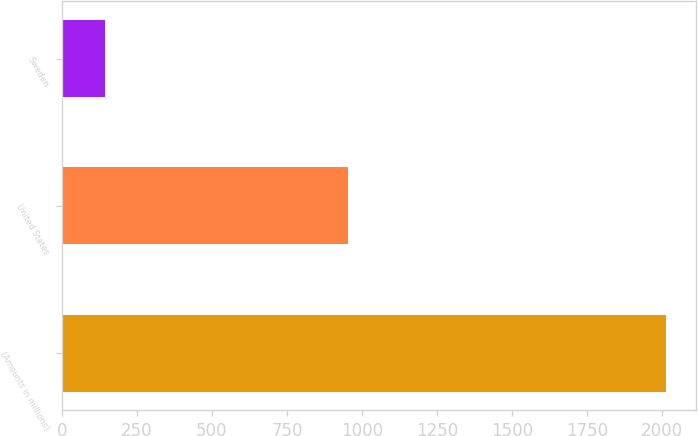<chart> <loc_0><loc_0><loc_500><loc_500><bar_chart><fcel>(Amounts in millions)<fcel>United States<fcel>Sweden<nl><fcel>2012<fcel>953.5<fcel>145<nl></chart> 